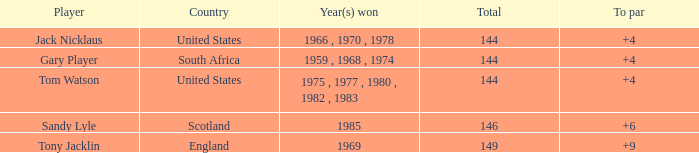Which player had a to par less than 9 and emerged victorious in 1985? Sandy Lyle. 